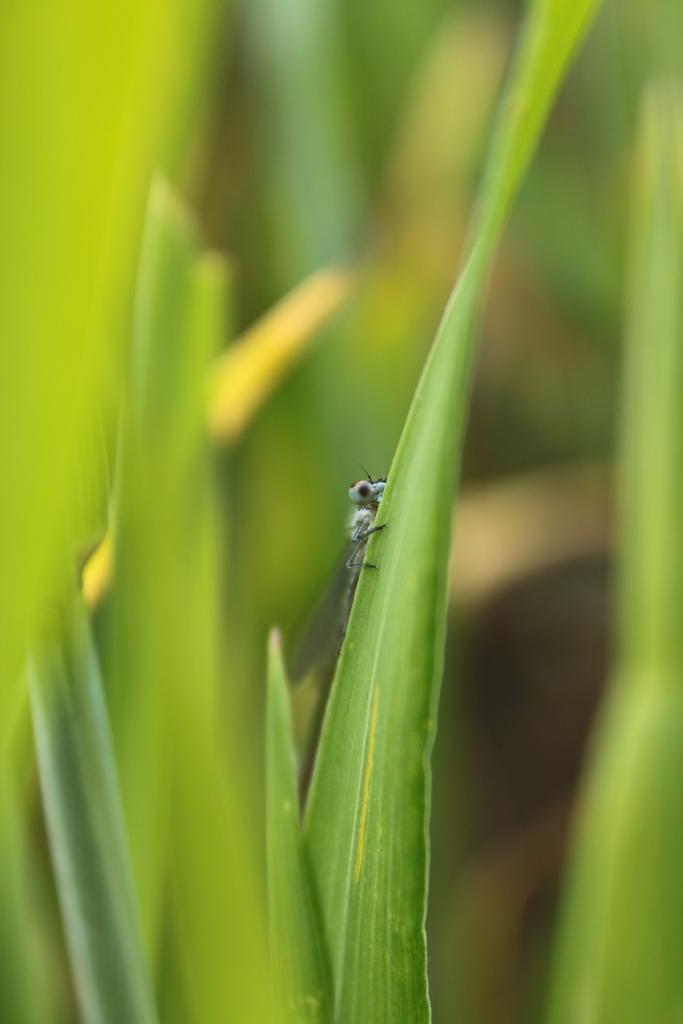What is present on the green leaf in the image? There is an insect on a green leaf in the image. What can be observed in the background of the image? The background is blurred and green. What type of request is the insect making to the judge in the image? There is no judge or request present in the image; it features an insect on a green leaf with a blurred green background. 